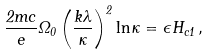Convert formula to latex. <formula><loc_0><loc_0><loc_500><loc_500>\frac { 2 m c } { e } \Omega _ { 0 } \left ( \frac { k \lambda } { \kappa } \right ) ^ { 2 } \ln \kappa = { \epsilon } H _ { c 1 } \, ,</formula> 